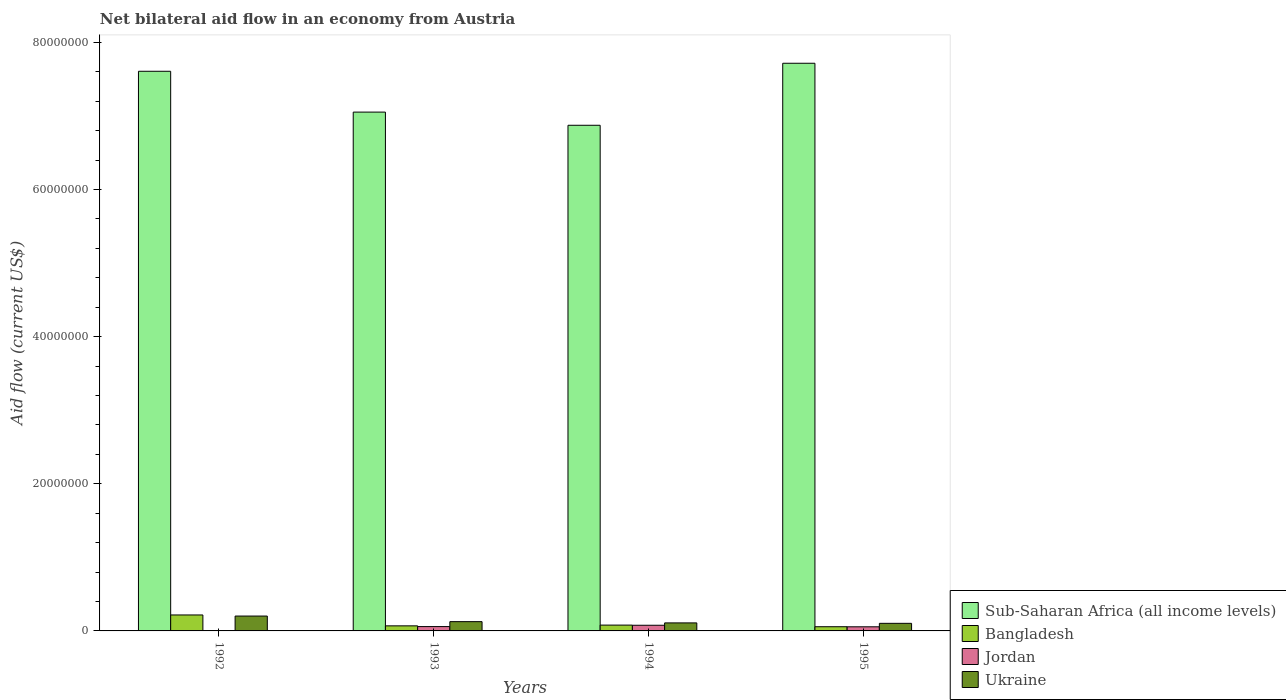How many groups of bars are there?
Keep it short and to the point. 4. How many bars are there on the 4th tick from the left?
Your answer should be compact. 4. What is the net bilateral aid flow in Ukraine in 1992?
Provide a short and direct response. 2.02e+06. Across all years, what is the maximum net bilateral aid flow in Bangladesh?
Make the answer very short. 2.17e+06. Across all years, what is the minimum net bilateral aid flow in Sub-Saharan Africa (all income levels)?
Offer a terse response. 6.87e+07. What is the total net bilateral aid flow in Bangladesh in the graph?
Keep it short and to the point. 4.22e+06. What is the difference between the net bilateral aid flow in Sub-Saharan Africa (all income levels) in 1993 and that in 1994?
Offer a very short reply. 1.79e+06. What is the difference between the net bilateral aid flow in Sub-Saharan Africa (all income levels) in 1992 and the net bilateral aid flow in Ukraine in 1993?
Your response must be concise. 7.48e+07. What is the average net bilateral aid flow in Sub-Saharan Africa (all income levels) per year?
Make the answer very short. 7.31e+07. In the year 1992, what is the difference between the net bilateral aid flow in Bangladesh and net bilateral aid flow in Sub-Saharan Africa (all income levels)?
Provide a short and direct response. -7.39e+07. In how many years, is the net bilateral aid flow in Bangladesh greater than 20000000 US$?
Keep it short and to the point. 0. What is the ratio of the net bilateral aid flow in Bangladesh in 1992 to that in 1993?
Ensure brevity in your answer.  3.14. Is the difference between the net bilateral aid flow in Bangladesh in 1992 and 1993 greater than the difference between the net bilateral aid flow in Sub-Saharan Africa (all income levels) in 1992 and 1993?
Provide a short and direct response. No. What is the difference between the highest and the second highest net bilateral aid flow in Bangladesh?
Your response must be concise. 1.38e+06. What is the difference between the highest and the lowest net bilateral aid flow in Jordan?
Provide a short and direct response. 7.70e+05. In how many years, is the net bilateral aid flow in Bangladesh greater than the average net bilateral aid flow in Bangladesh taken over all years?
Your answer should be compact. 1. Is the sum of the net bilateral aid flow in Bangladesh in 1993 and 1995 greater than the maximum net bilateral aid flow in Sub-Saharan Africa (all income levels) across all years?
Offer a terse response. No. Are all the bars in the graph horizontal?
Offer a very short reply. No. Are the values on the major ticks of Y-axis written in scientific E-notation?
Your answer should be compact. No. Does the graph contain any zero values?
Offer a terse response. Yes. Does the graph contain grids?
Make the answer very short. No. How many legend labels are there?
Your answer should be compact. 4. What is the title of the graph?
Provide a succinct answer. Net bilateral aid flow in an economy from Austria. What is the label or title of the X-axis?
Make the answer very short. Years. What is the Aid flow (current US$) in Sub-Saharan Africa (all income levels) in 1992?
Offer a terse response. 7.61e+07. What is the Aid flow (current US$) in Bangladesh in 1992?
Offer a terse response. 2.17e+06. What is the Aid flow (current US$) in Jordan in 1992?
Give a very brief answer. 0. What is the Aid flow (current US$) in Ukraine in 1992?
Your answer should be very brief. 2.02e+06. What is the Aid flow (current US$) in Sub-Saharan Africa (all income levels) in 1993?
Your answer should be very brief. 7.05e+07. What is the Aid flow (current US$) in Bangladesh in 1993?
Offer a terse response. 6.90e+05. What is the Aid flow (current US$) in Jordan in 1993?
Provide a short and direct response. 5.90e+05. What is the Aid flow (current US$) in Ukraine in 1993?
Keep it short and to the point. 1.26e+06. What is the Aid flow (current US$) of Sub-Saharan Africa (all income levels) in 1994?
Provide a short and direct response. 6.87e+07. What is the Aid flow (current US$) in Bangladesh in 1994?
Offer a very short reply. 7.90e+05. What is the Aid flow (current US$) in Jordan in 1994?
Your response must be concise. 7.70e+05. What is the Aid flow (current US$) of Ukraine in 1994?
Give a very brief answer. 1.09e+06. What is the Aid flow (current US$) of Sub-Saharan Africa (all income levels) in 1995?
Your answer should be very brief. 7.72e+07. What is the Aid flow (current US$) of Bangladesh in 1995?
Make the answer very short. 5.70e+05. What is the Aid flow (current US$) of Jordan in 1995?
Offer a very short reply. 5.60e+05. What is the Aid flow (current US$) of Ukraine in 1995?
Offer a very short reply. 1.03e+06. Across all years, what is the maximum Aid flow (current US$) in Sub-Saharan Africa (all income levels)?
Keep it short and to the point. 7.72e+07. Across all years, what is the maximum Aid flow (current US$) of Bangladesh?
Keep it short and to the point. 2.17e+06. Across all years, what is the maximum Aid flow (current US$) of Jordan?
Ensure brevity in your answer.  7.70e+05. Across all years, what is the maximum Aid flow (current US$) of Ukraine?
Ensure brevity in your answer.  2.02e+06. Across all years, what is the minimum Aid flow (current US$) of Sub-Saharan Africa (all income levels)?
Your answer should be compact. 6.87e+07. Across all years, what is the minimum Aid flow (current US$) of Bangladesh?
Provide a short and direct response. 5.70e+05. Across all years, what is the minimum Aid flow (current US$) of Ukraine?
Ensure brevity in your answer.  1.03e+06. What is the total Aid flow (current US$) of Sub-Saharan Africa (all income levels) in the graph?
Your response must be concise. 2.92e+08. What is the total Aid flow (current US$) in Bangladesh in the graph?
Provide a succinct answer. 4.22e+06. What is the total Aid flow (current US$) of Jordan in the graph?
Give a very brief answer. 1.92e+06. What is the total Aid flow (current US$) in Ukraine in the graph?
Provide a succinct answer. 5.40e+06. What is the difference between the Aid flow (current US$) in Sub-Saharan Africa (all income levels) in 1992 and that in 1993?
Give a very brief answer. 5.55e+06. What is the difference between the Aid flow (current US$) in Bangladesh in 1992 and that in 1993?
Provide a short and direct response. 1.48e+06. What is the difference between the Aid flow (current US$) of Ukraine in 1992 and that in 1993?
Your answer should be very brief. 7.60e+05. What is the difference between the Aid flow (current US$) of Sub-Saharan Africa (all income levels) in 1992 and that in 1994?
Ensure brevity in your answer.  7.34e+06. What is the difference between the Aid flow (current US$) of Bangladesh in 1992 and that in 1994?
Make the answer very short. 1.38e+06. What is the difference between the Aid flow (current US$) of Ukraine in 1992 and that in 1994?
Give a very brief answer. 9.30e+05. What is the difference between the Aid flow (current US$) in Sub-Saharan Africa (all income levels) in 1992 and that in 1995?
Give a very brief answer. -1.09e+06. What is the difference between the Aid flow (current US$) of Bangladesh in 1992 and that in 1995?
Ensure brevity in your answer.  1.60e+06. What is the difference between the Aid flow (current US$) in Ukraine in 1992 and that in 1995?
Your response must be concise. 9.90e+05. What is the difference between the Aid flow (current US$) in Sub-Saharan Africa (all income levels) in 1993 and that in 1994?
Keep it short and to the point. 1.79e+06. What is the difference between the Aid flow (current US$) of Bangladesh in 1993 and that in 1994?
Make the answer very short. -1.00e+05. What is the difference between the Aid flow (current US$) in Jordan in 1993 and that in 1994?
Ensure brevity in your answer.  -1.80e+05. What is the difference between the Aid flow (current US$) in Ukraine in 1993 and that in 1994?
Ensure brevity in your answer.  1.70e+05. What is the difference between the Aid flow (current US$) of Sub-Saharan Africa (all income levels) in 1993 and that in 1995?
Provide a succinct answer. -6.64e+06. What is the difference between the Aid flow (current US$) of Bangladesh in 1993 and that in 1995?
Provide a short and direct response. 1.20e+05. What is the difference between the Aid flow (current US$) in Jordan in 1993 and that in 1995?
Offer a terse response. 3.00e+04. What is the difference between the Aid flow (current US$) in Ukraine in 1993 and that in 1995?
Keep it short and to the point. 2.30e+05. What is the difference between the Aid flow (current US$) in Sub-Saharan Africa (all income levels) in 1994 and that in 1995?
Ensure brevity in your answer.  -8.43e+06. What is the difference between the Aid flow (current US$) in Bangladesh in 1994 and that in 1995?
Ensure brevity in your answer.  2.20e+05. What is the difference between the Aid flow (current US$) of Jordan in 1994 and that in 1995?
Your answer should be compact. 2.10e+05. What is the difference between the Aid flow (current US$) of Sub-Saharan Africa (all income levels) in 1992 and the Aid flow (current US$) of Bangladesh in 1993?
Provide a succinct answer. 7.54e+07. What is the difference between the Aid flow (current US$) in Sub-Saharan Africa (all income levels) in 1992 and the Aid flow (current US$) in Jordan in 1993?
Provide a succinct answer. 7.55e+07. What is the difference between the Aid flow (current US$) in Sub-Saharan Africa (all income levels) in 1992 and the Aid flow (current US$) in Ukraine in 1993?
Your answer should be compact. 7.48e+07. What is the difference between the Aid flow (current US$) of Bangladesh in 1992 and the Aid flow (current US$) of Jordan in 1993?
Your answer should be compact. 1.58e+06. What is the difference between the Aid flow (current US$) in Bangladesh in 1992 and the Aid flow (current US$) in Ukraine in 1993?
Offer a very short reply. 9.10e+05. What is the difference between the Aid flow (current US$) of Sub-Saharan Africa (all income levels) in 1992 and the Aid flow (current US$) of Bangladesh in 1994?
Offer a very short reply. 7.53e+07. What is the difference between the Aid flow (current US$) of Sub-Saharan Africa (all income levels) in 1992 and the Aid flow (current US$) of Jordan in 1994?
Your answer should be very brief. 7.53e+07. What is the difference between the Aid flow (current US$) in Sub-Saharan Africa (all income levels) in 1992 and the Aid flow (current US$) in Ukraine in 1994?
Your answer should be very brief. 7.50e+07. What is the difference between the Aid flow (current US$) in Bangladesh in 1992 and the Aid flow (current US$) in Jordan in 1994?
Your answer should be very brief. 1.40e+06. What is the difference between the Aid flow (current US$) of Bangladesh in 1992 and the Aid flow (current US$) of Ukraine in 1994?
Your answer should be very brief. 1.08e+06. What is the difference between the Aid flow (current US$) of Sub-Saharan Africa (all income levels) in 1992 and the Aid flow (current US$) of Bangladesh in 1995?
Provide a succinct answer. 7.55e+07. What is the difference between the Aid flow (current US$) of Sub-Saharan Africa (all income levels) in 1992 and the Aid flow (current US$) of Jordan in 1995?
Give a very brief answer. 7.55e+07. What is the difference between the Aid flow (current US$) of Sub-Saharan Africa (all income levels) in 1992 and the Aid flow (current US$) of Ukraine in 1995?
Keep it short and to the point. 7.50e+07. What is the difference between the Aid flow (current US$) in Bangladesh in 1992 and the Aid flow (current US$) in Jordan in 1995?
Provide a succinct answer. 1.61e+06. What is the difference between the Aid flow (current US$) of Bangladesh in 1992 and the Aid flow (current US$) of Ukraine in 1995?
Give a very brief answer. 1.14e+06. What is the difference between the Aid flow (current US$) in Sub-Saharan Africa (all income levels) in 1993 and the Aid flow (current US$) in Bangladesh in 1994?
Offer a terse response. 6.97e+07. What is the difference between the Aid flow (current US$) of Sub-Saharan Africa (all income levels) in 1993 and the Aid flow (current US$) of Jordan in 1994?
Provide a short and direct response. 6.98e+07. What is the difference between the Aid flow (current US$) of Sub-Saharan Africa (all income levels) in 1993 and the Aid flow (current US$) of Ukraine in 1994?
Provide a succinct answer. 6.94e+07. What is the difference between the Aid flow (current US$) in Bangladesh in 1993 and the Aid flow (current US$) in Ukraine in 1994?
Your response must be concise. -4.00e+05. What is the difference between the Aid flow (current US$) in Jordan in 1993 and the Aid flow (current US$) in Ukraine in 1994?
Keep it short and to the point. -5.00e+05. What is the difference between the Aid flow (current US$) in Sub-Saharan Africa (all income levels) in 1993 and the Aid flow (current US$) in Bangladesh in 1995?
Offer a very short reply. 7.00e+07. What is the difference between the Aid flow (current US$) of Sub-Saharan Africa (all income levels) in 1993 and the Aid flow (current US$) of Jordan in 1995?
Ensure brevity in your answer.  7.00e+07. What is the difference between the Aid flow (current US$) in Sub-Saharan Africa (all income levels) in 1993 and the Aid flow (current US$) in Ukraine in 1995?
Make the answer very short. 6.95e+07. What is the difference between the Aid flow (current US$) of Bangladesh in 1993 and the Aid flow (current US$) of Jordan in 1995?
Provide a short and direct response. 1.30e+05. What is the difference between the Aid flow (current US$) in Bangladesh in 1993 and the Aid flow (current US$) in Ukraine in 1995?
Your response must be concise. -3.40e+05. What is the difference between the Aid flow (current US$) in Jordan in 1993 and the Aid flow (current US$) in Ukraine in 1995?
Your answer should be very brief. -4.40e+05. What is the difference between the Aid flow (current US$) in Sub-Saharan Africa (all income levels) in 1994 and the Aid flow (current US$) in Bangladesh in 1995?
Provide a short and direct response. 6.82e+07. What is the difference between the Aid flow (current US$) in Sub-Saharan Africa (all income levels) in 1994 and the Aid flow (current US$) in Jordan in 1995?
Your response must be concise. 6.82e+07. What is the difference between the Aid flow (current US$) in Sub-Saharan Africa (all income levels) in 1994 and the Aid flow (current US$) in Ukraine in 1995?
Make the answer very short. 6.77e+07. What is the average Aid flow (current US$) of Sub-Saharan Africa (all income levels) per year?
Give a very brief answer. 7.31e+07. What is the average Aid flow (current US$) of Bangladesh per year?
Provide a short and direct response. 1.06e+06. What is the average Aid flow (current US$) in Ukraine per year?
Keep it short and to the point. 1.35e+06. In the year 1992, what is the difference between the Aid flow (current US$) in Sub-Saharan Africa (all income levels) and Aid flow (current US$) in Bangladesh?
Provide a succinct answer. 7.39e+07. In the year 1992, what is the difference between the Aid flow (current US$) of Sub-Saharan Africa (all income levels) and Aid flow (current US$) of Ukraine?
Keep it short and to the point. 7.40e+07. In the year 1993, what is the difference between the Aid flow (current US$) of Sub-Saharan Africa (all income levels) and Aid flow (current US$) of Bangladesh?
Your response must be concise. 6.98e+07. In the year 1993, what is the difference between the Aid flow (current US$) of Sub-Saharan Africa (all income levels) and Aid flow (current US$) of Jordan?
Keep it short and to the point. 6.99e+07. In the year 1993, what is the difference between the Aid flow (current US$) in Sub-Saharan Africa (all income levels) and Aid flow (current US$) in Ukraine?
Offer a very short reply. 6.93e+07. In the year 1993, what is the difference between the Aid flow (current US$) of Bangladesh and Aid flow (current US$) of Jordan?
Provide a short and direct response. 1.00e+05. In the year 1993, what is the difference between the Aid flow (current US$) in Bangladesh and Aid flow (current US$) in Ukraine?
Keep it short and to the point. -5.70e+05. In the year 1993, what is the difference between the Aid flow (current US$) of Jordan and Aid flow (current US$) of Ukraine?
Your answer should be very brief. -6.70e+05. In the year 1994, what is the difference between the Aid flow (current US$) of Sub-Saharan Africa (all income levels) and Aid flow (current US$) of Bangladesh?
Your response must be concise. 6.79e+07. In the year 1994, what is the difference between the Aid flow (current US$) of Sub-Saharan Africa (all income levels) and Aid flow (current US$) of Jordan?
Ensure brevity in your answer.  6.80e+07. In the year 1994, what is the difference between the Aid flow (current US$) of Sub-Saharan Africa (all income levels) and Aid flow (current US$) of Ukraine?
Your response must be concise. 6.76e+07. In the year 1994, what is the difference between the Aid flow (current US$) in Bangladesh and Aid flow (current US$) in Jordan?
Give a very brief answer. 2.00e+04. In the year 1994, what is the difference between the Aid flow (current US$) in Bangladesh and Aid flow (current US$) in Ukraine?
Provide a short and direct response. -3.00e+05. In the year 1994, what is the difference between the Aid flow (current US$) in Jordan and Aid flow (current US$) in Ukraine?
Provide a short and direct response. -3.20e+05. In the year 1995, what is the difference between the Aid flow (current US$) of Sub-Saharan Africa (all income levels) and Aid flow (current US$) of Bangladesh?
Your answer should be compact. 7.66e+07. In the year 1995, what is the difference between the Aid flow (current US$) of Sub-Saharan Africa (all income levels) and Aid flow (current US$) of Jordan?
Keep it short and to the point. 7.66e+07. In the year 1995, what is the difference between the Aid flow (current US$) of Sub-Saharan Africa (all income levels) and Aid flow (current US$) of Ukraine?
Ensure brevity in your answer.  7.61e+07. In the year 1995, what is the difference between the Aid flow (current US$) in Bangladesh and Aid flow (current US$) in Jordan?
Your answer should be very brief. 10000. In the year 1995, what is the difference between the Aid flow (current US$) of Bangladesh and Aid flow (current US$) of Ukraine?
Make the answer very short. -4.60e+05. In the year 1995, what is the difference between the Aid flow (current US$) in Jordan and Aid flow (current US$) in Ukraine?
Offer a terse response. -4.70e+05. What is the ratio of the Aid flow (current US$) of Sub-Saharan Africa (all income levels) in 1992 to that in 1993?
Give a very brief answer. 1.08. What is the ratio of the Aid flow (current US$) in Bangladesh in 1992 to that in 1993?
Provide a short and direct response. 3.14. What is the ratio of the Aid flow (current US$) in Ukraine in 1992 to that in 1993?
Your answer should be compact. 1.6. What is the ratio of the Aid flow (current US$) of Sub-Saharan Africa (all income levels) in 1992 to that in 1994?
Ensure brevity in your answer.  1.11. What is the ratio of the Aid flow (current US$) in Bangladesh in 1992 to that in 1994?
Provide a succinct answer. 2.75. What is the ratio of the Aid flow (current US$) in Ukraine in 1992 to that in 1994?
Ensure brevity in your answer.  1.85. What is the ratio of the Aid flow (current US$) in Sub-Saharan Africa (all income levels) in 1992 to that in 1995?
Give a very brief answer. 0.99. What is the ratio of the Aid flow (current US$) of Bangladesh in 1992 to that in 1995?
Keep it short and to the point. 3.81. What is the ratio of the Aid flow (current US$) in Ukraine in 1992 to that in 1995?
Provide a succinct answer. 1.96. What is the ratio of the Aid flow (current US$) in Bangladesh in 1993 to that in 1994?
Offer a terse response. 0.87. What is the ratio of the Aid flow (current US$) of Jordan in 1993 to that in 1994?
Provide a short and direct response. 0.77. What is the ratio of the Aid flow (current US$) in Ukraine in 1993 to that in 1994?
Your answer should be very brief. 1.16. What is the ratio of the Aid flow (current US$) of Sub-Saharan Africa (all income levels) in 1993 to that in 1995?
Make the answer very short. 0.91. What is the ratio of the Aid flow (current US$) of Bangladesh in 1993 to that in 1995?
Provide a succinct answer. 1.21. What is the ratio of the Aid flow (current US$) in Jordan in 1993 to that in 1995?
Provide a succinct answer. 1.05. What is the ratio of the Aid flow (current US$) of Ukraine in 1993 to that in 1995?
Make the answer very short. 1.22. What is the ratio of the Aid flow (current US$) of Sub-Saharan Africa (all income levels) in 1994 to that in 1995?
Offer a terse response. 0.89. What is the ratio of the Aid flow (current US$) of Bangladesh in 1994 to that in 1995?
Your response must be concise. 1.39. What is the ratio of the Aid flow (current US$) of Jordan in 1994 to that in 1995?
Make the answer very short. 1.38. What is the ratio of the Aid flow (current US$) of Ukraine in 1994 to that in 1995?
Give a very brief answer. 1.06. What is the difference between the highest and the second highest Aid flow (current US$) of Sub-Saharan Africa (all income levels)?
Offer a terse response. 1.09e+06. What is the difference between the highest and the second highest Aid flow (current US$) in Bangladesh?
Ensure brevity in your answer.  1.38e+06. What is the difference between the highest and the second highest Aid flow (current US$) of Jordan?
Provide a short and direct response. 1.80e+05. What is the difference between the highest and the second highest Aid flow (current US$) of Ukraine?
Your response must be concise. 7.60e+05. What is the difference between the highest and the lowest Aid flow (current US$) in Sub-Saharan Africa (all income levels)?
Your answer should be very brief. 8.43e+06. What is the difference between the highest and the lowest Aid flow (current US$) of Bangladesh?
Offer a very short reply. 1.60e+06. What is the difference between the highest and the lowest Aid flow (current US$) in Jordan?
Provide a succinct answer. 7.70e+05. What is the difference between the highest and the lowest Aid flow (current US$) in Ukraine?
Your answer should be very brief. 9.90e+05. 